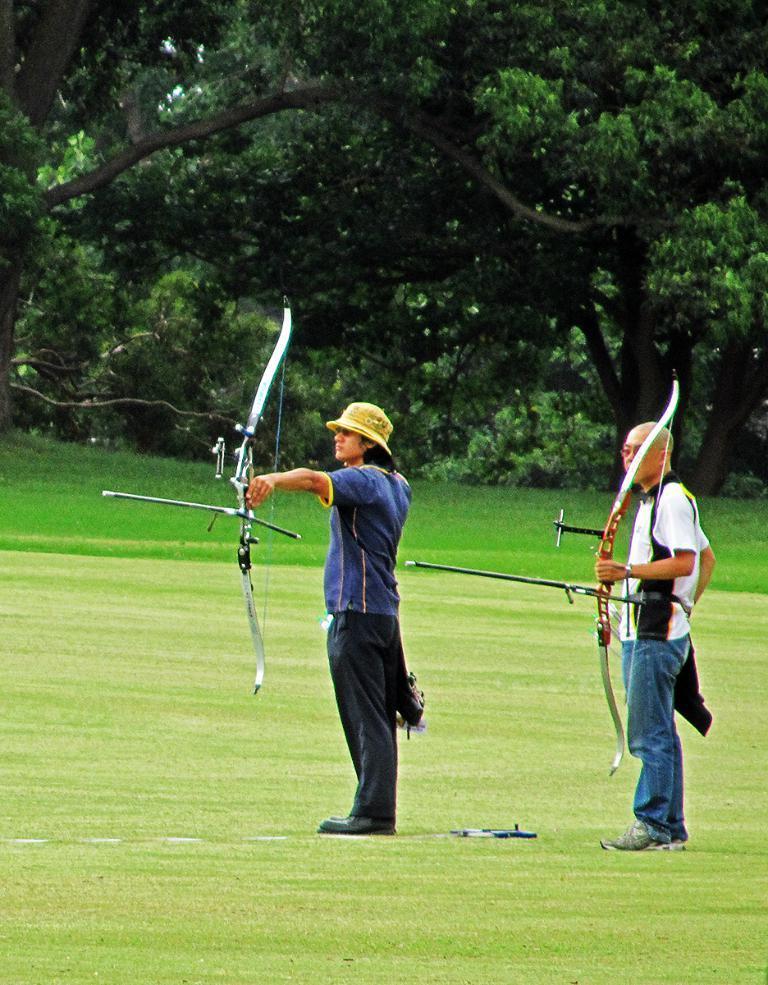Describe this image in one or two sentences. In the center of the image there are two persons holding bows in their hands. At the bottom of the image there is grass. In the background of the image there are trees. 